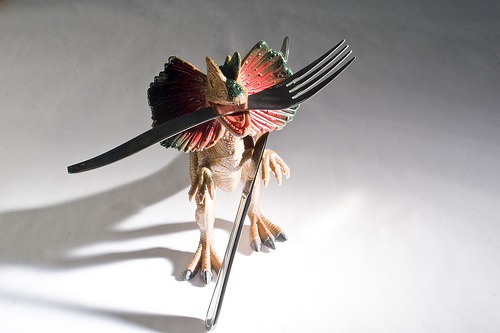<image>
Is there a fork on the table? No. The fork is not positioned on the table. They may be near each other, but the fork is not supported by or resting on top of the table. Where is the dinosaur in relation to the fork? Is it behind the fork? Yes. From this viewpoint, the dinosaur is positioned behind the fork, with the fork partially or fully occluding the dinosaur. Where is the fork in relation to the toy? Is it in the toy? Yes. The fork is contained within or inside the toy, showing a containment relationship. Is the dragon in the shadow? No. The dragon is not contained within the shadow. These objects have a different spatial relationship. 